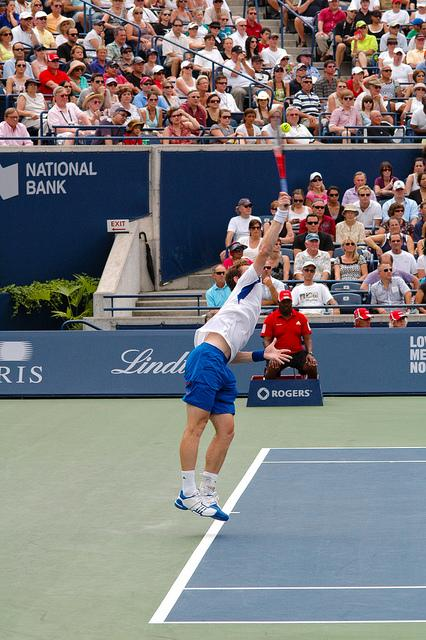Why is his arm up in the air? Please explain your reasoning. reach. The man is trying to reach the ball. 